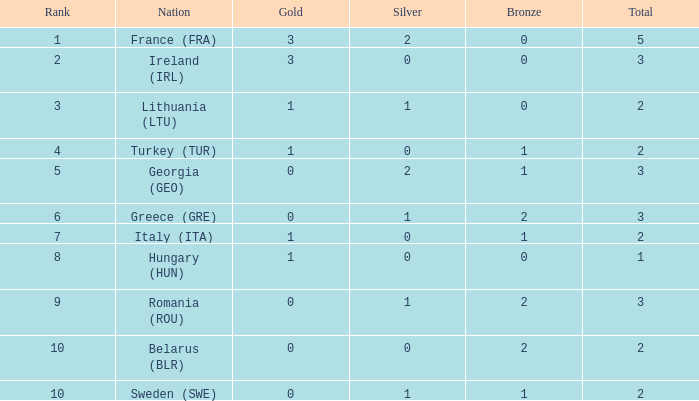What is the combined amount when gold is less than 0 and silver is under 1? None. 